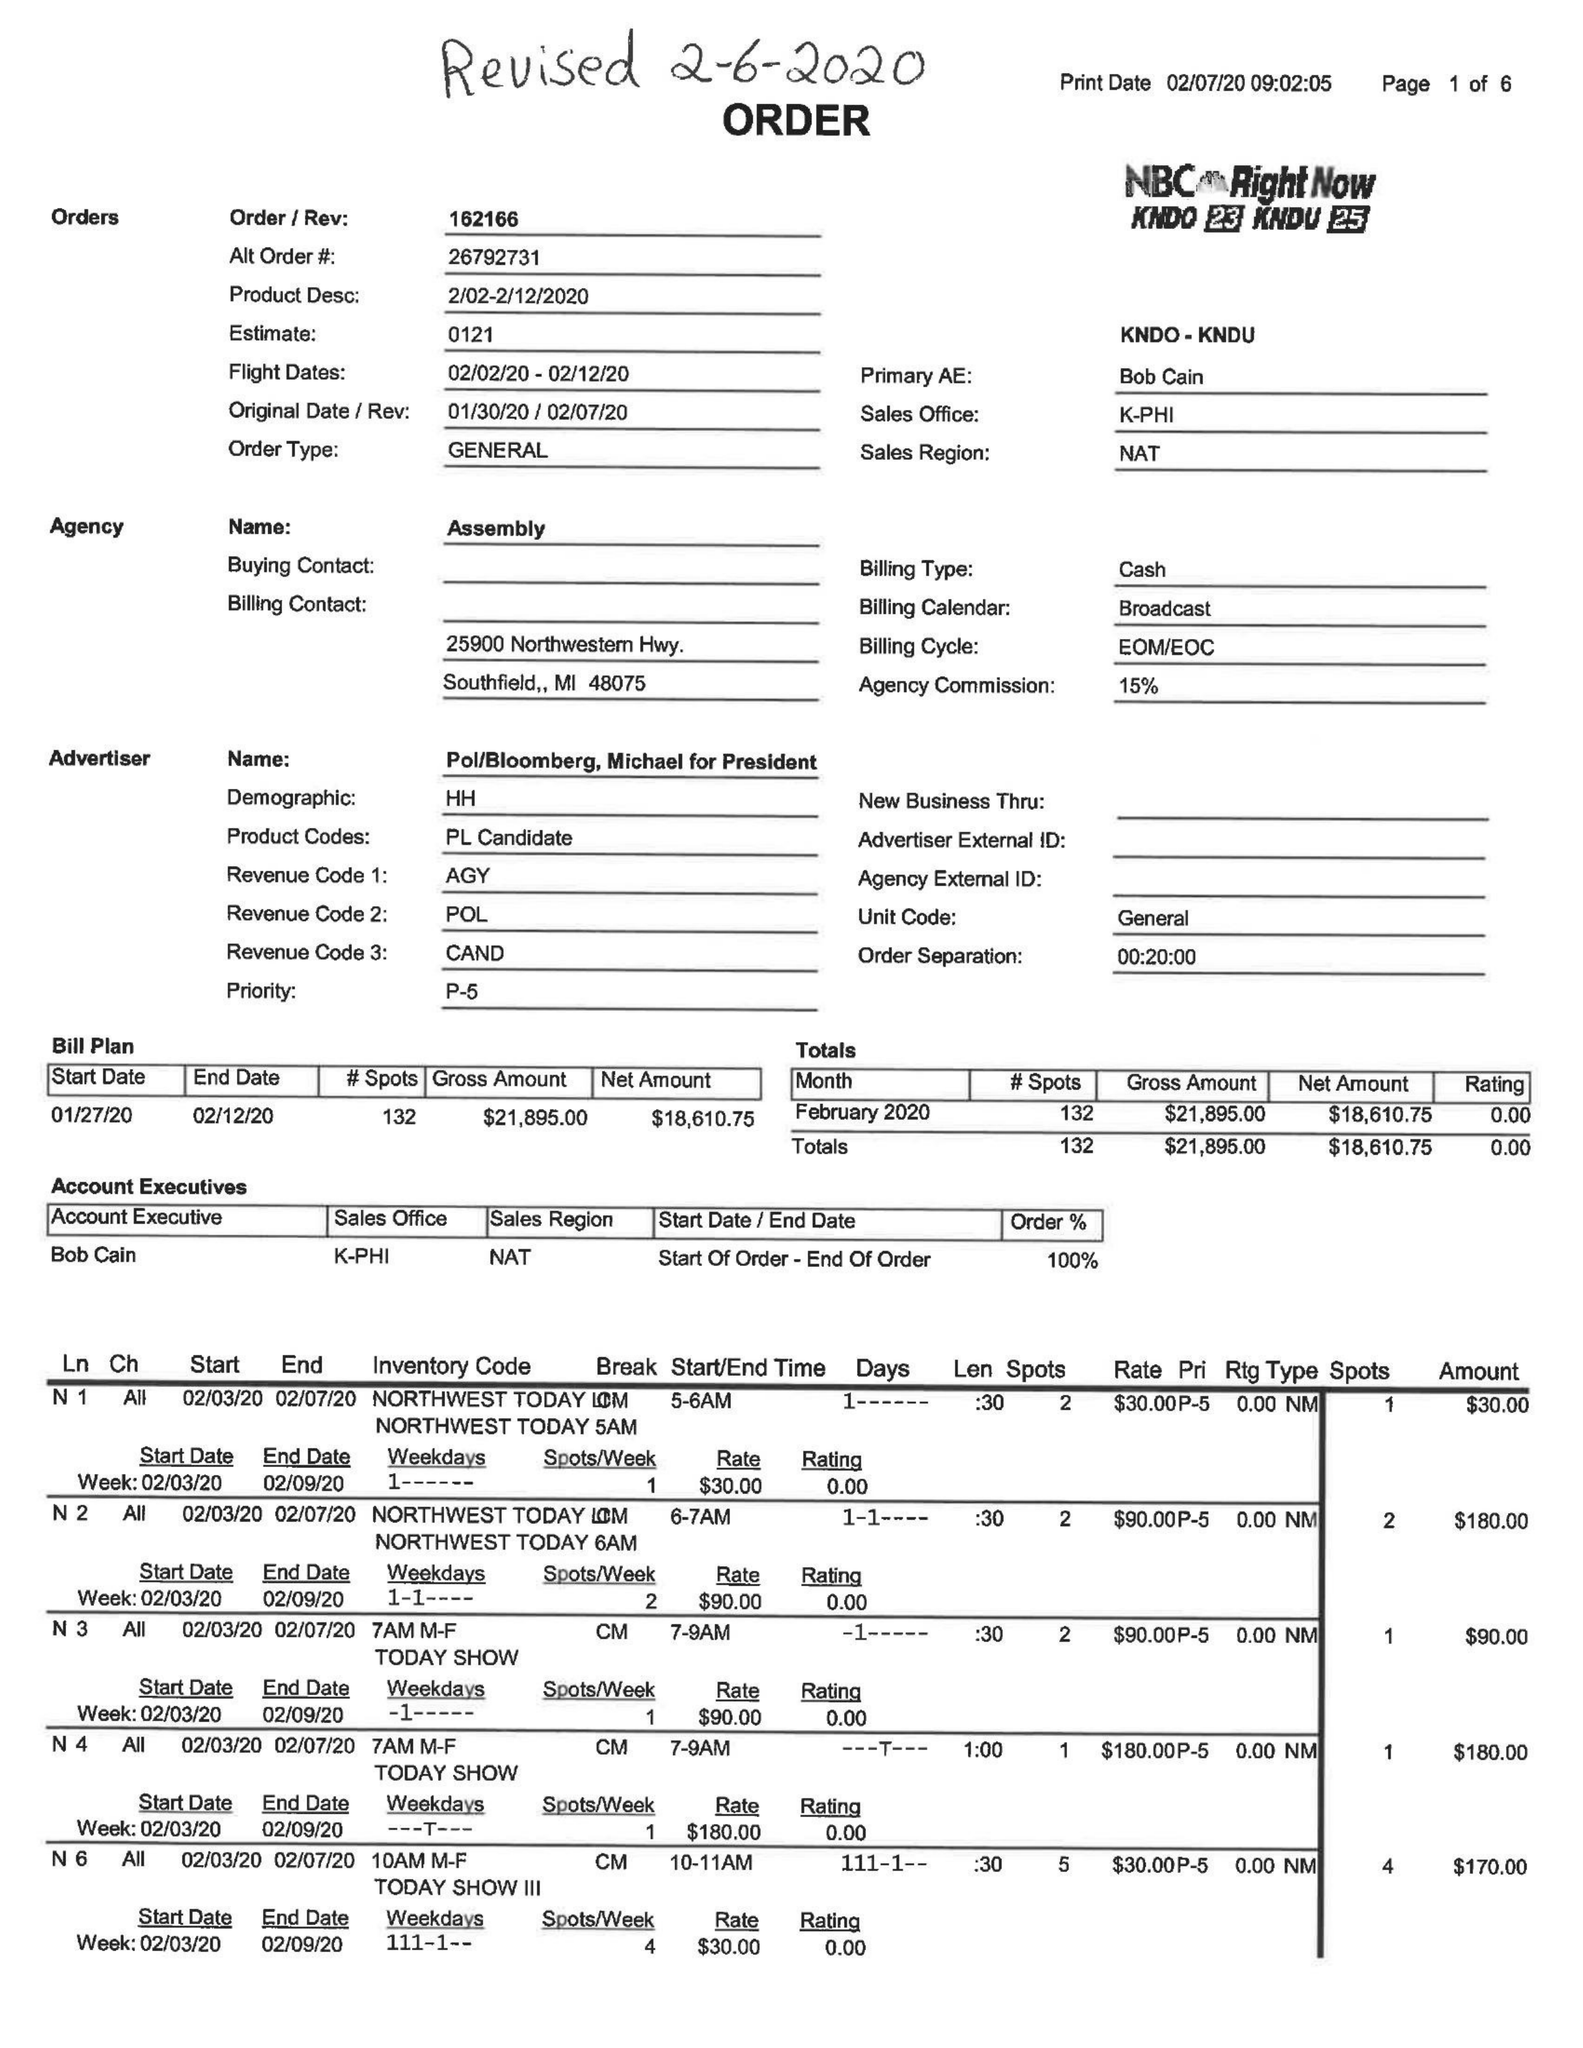What is the value for the flight_from?
Answer the question using a single word or phrase. 02/02/20 